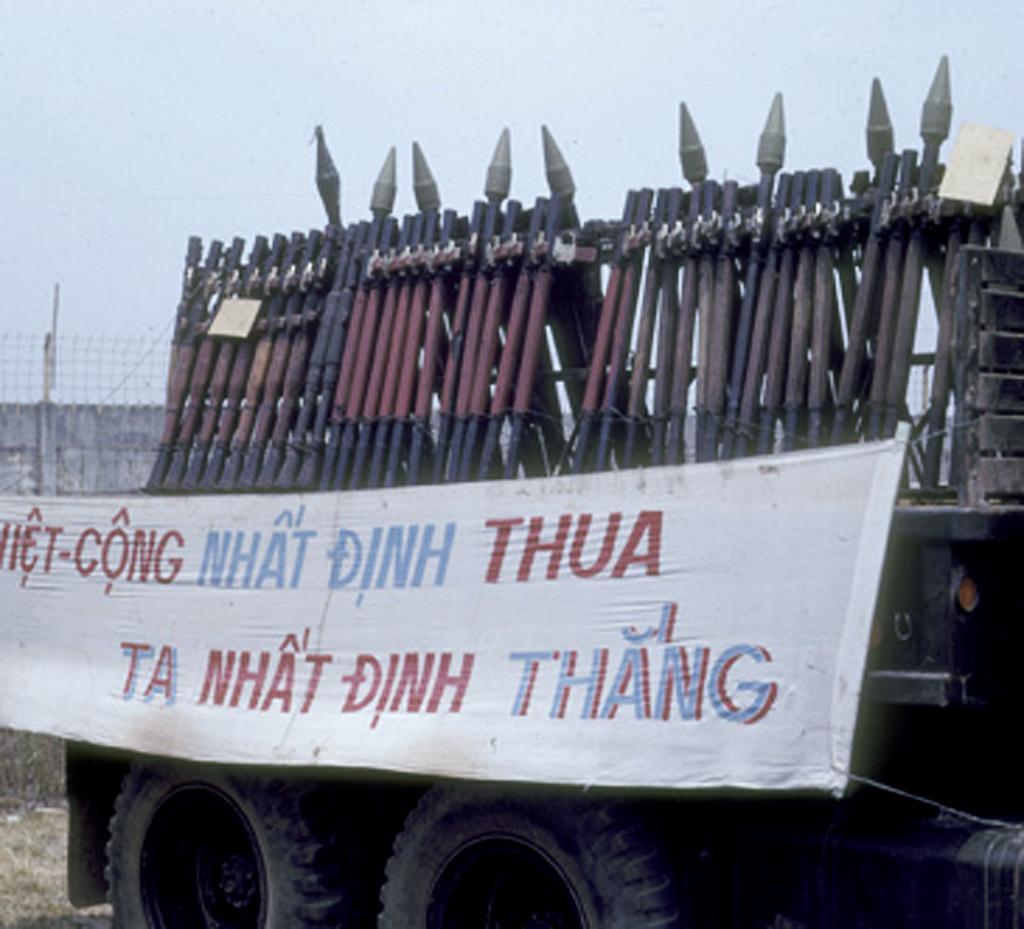In one or two sentences, can you explain what this image depicts? In this image we can see a group of poles and a banner with text is placed on a vehicle. In the background we can see a fence and the sky. 